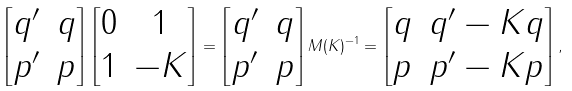Convert formula to latex. <formula><loc_0><loc_0><loc_500><loc_500>\left [ \begin{matrix} q ^ { \prime } & q \\ p ^ { \prime } & p \end{matrix} \right ] \left [ \begin{matrix} 0 & 1 \\ 1 & - K \end{matrix} \right ] = \left [ \begin{matrix} q ^ { \prime } & q \\ p ^ { \prime } & p \end{matrix} \right ] M ( K ) ^ { - 1 } = \left [ \begin{matrix} q & q ^ { \prime } - K q \\ p & p ^ { \prime } - K p \end{matrix} \right ] ,</formula> 